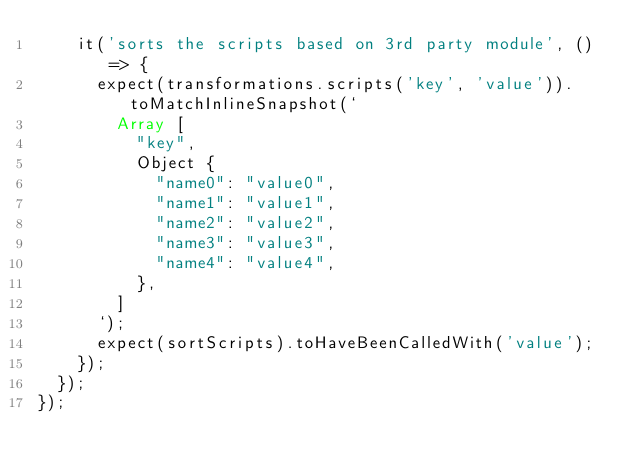Convert code to text. <code><loc_0><loc_0><loc_500><loc_500><_TypeScript_>    it('sorts the scripts based on 3rd party module', () => {
      expect(transformations.scripts('key', 'value')).toMatchInlineSnapshot(`
        Array [
          "key",
          Object {
            "name0": "value0",
            "name1": "value1",
            "name2": "value2",
            "name3": "value3",
            "name4": "value4",
          },
        ]
      `);
      expect(sortScripts).toHaveBeenCalledWith('value');
    });
  });
});
</code> 